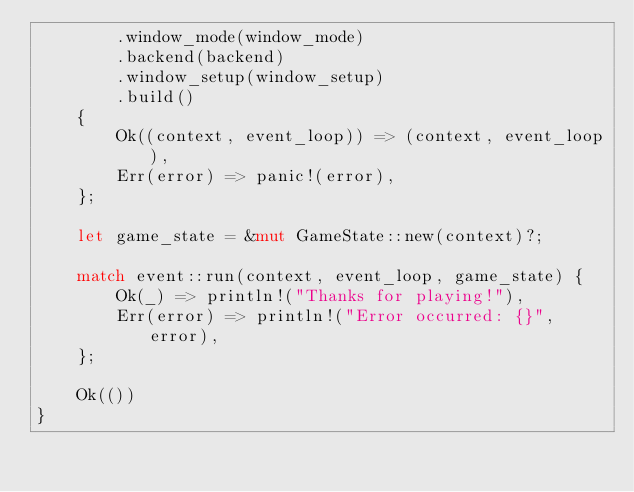Convert code to text. <code><loc_0><loc_0><loc_500><loc_500><_Rust_>        .window_mode(window_mode)
        .backend(backend)
        .window_setup(window_setup)
        .build()
    {
        Ok((context, event_loop)) => (context, event_loop),
        Err(error) => panic!(error),
    };

    let game_state = &mut GameState::new(context)?;

    match event::run(context, event_loop, game_state) {
        Ok(_) => println!("Thanks for playing!"),
        Err(error) => println!("Error occurred: {}", error),
    };

    Ok(())
}
</code> 